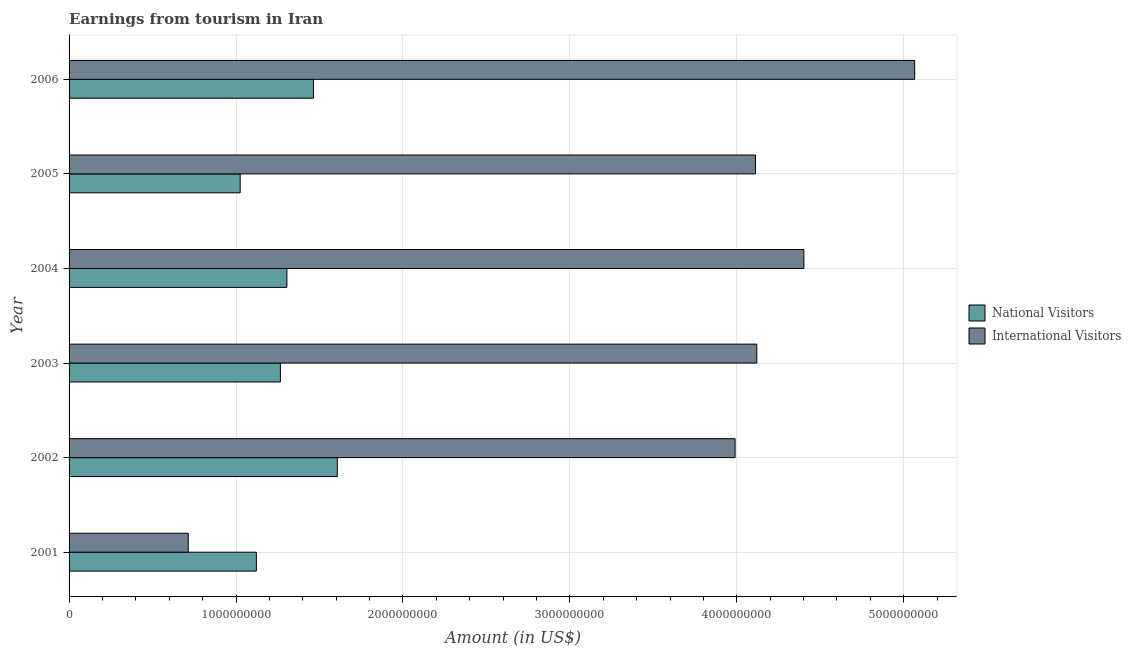How many different coloured bars are there?
Offer a terse response. 2. How many groups of bars are there?
Your response must be concise. 6. Are the number of bars per tick equal to the number of legend labels?
Offer a terse response. Yes. Are the number of bars on each tick of the Y-axis equal?
Offer a terse response. Yes. How many bars are there on the 4th tick from the bottom?
Provide a succinct answer. 2. What is the amount earned from national visitors in 2001?
Your response must be concise. 1.12e+09. Across all years, what is the maximum amount earned from national visitors?
Ensure brevity in your answer.  1.61e+09. Across all years, what is the minimum amount earned from international visitors?
Provide a succinct answer. 7.14e+08. In which year was the amount earned from international visitors maximum?
Provide a succinct answer. 2006. In which year was the amount earned from national visitors minimum?
Your response must be concise. 2005. What is the total amount earned from national visitors in the graph?
Offer a terse response. 7.79e+09. What is the difference between the amount earned from international visitors in 2003 and that in 2004?
Your answer should be compact. -2.82e+08. What is the difference between the amount earned from international visitors in 2001 and the amount earned from national visitors in 2005?
Offer a terse response. -3.11e+08. What is the average amount earned from international visitors per year?
Your response must be concise. 3.73e+09. In the year 2002, what is the difference between the amount earned from national visitors and amount earned from international visitors?
Provide a short and direct response. -2.38e+09. In how many years, is the amount earned from international visitors greater than 4000000000 US$?
Ensure brevity in your answer.  4. What is the ratio of the amount earned from national visitors in 2001 to that in 2002?
Make the answer very short. 0.7. Is the amount earned from national visitors in 2001 less than that in 2004?
Ensure brevity in your answer.  Yes. Is the difference between the amount earned from international visitors in 2001 and 2006 greater than the difference between the amount earned from national visitors in 2001 and 2006?
Your response must be concise. No. What is the difference between the highest and the second highest amount earned from international visitors?
Offer a very short reply. 6.64e+08. What is the difference between the highest and the lowest amount earned from international visitors?
Ensure brevity in your answer.  4.35e+09. What does the 2nd bar from the top in 2006 represents?
Provide a succinct answer. National Visitors. What does the 2nd bar from the bottom in 2002 represents?
Provide a succinct answer. International Visitors. How many years are there in the graph?
Offer a very short reply. 6. Are the values on the major ticks of X-axis written in scientific E-notation?
Make the answer very short. No. Where does the legend appear in the graph?
Your response must be concise. Center right. How many legend labels are there?
Keep it short and to the point. 2. How are the legend labels stacked?
Offer a terse response. Vertical. What is the title of the graph?
Provide a short and direct response. Earnings from tourism in Iran. What is the label or title of the X-axis?
Your answer should be very brief. Amount (in US$). What is the Amount (in US$) of National Visitors in 2001?
Give a very brief answer. 1.12e+09. What is the Amount (in US$) of International Visitors in 2001?
Offer a very short reply. 7.14e+08. What is the Amount (in US$) in National Visitors in 2002?
Your answer should be very brief. 1.61e+09. What is the Amount (in US$) of International Visitors in 2002?
Your answer should be compact. 3.99e+09. What is the Amount (in US$) of National Visitors in 2003?
Make the answer very short. 1.27e+09. What is the Amount (in US$) of International Visitors in 2003?
Your answer should be very brief. 4.12e+09. What is the Amount (in US$) of National Visitors in 2004?
Your answer should be compact. 1.30e+09. What is the Amount (in US$) of International Visitors in 2004?
Offer a very short reply. 4.40e+09. What is the Amount (in US$) of National Visitors in 2005?
Your answer should be compact. 1.02e+09. What is the Amount (in US$) of International Visitors in 2005?
Make the answer very short. 4.11e+09. What is the Amount (in US$) of National Visitors in 2006?
Your answer should be compact. 1.46e+09. What is the Amount (in US$) of International Visitors in 2006?
Ensure brevity in your answer.  5.07e+09. Across all years, what is the maximum Amount (in US$) in National Visitors?
Your response must be concise. 1.61e+09. Across all years, what is the maximum Amount (in US$) in International Visitors?
Offer a very short reply. 5.07e+09. Across all years, what is the minimum Amount (in US$) of National Visitors?
Your response must be concise. 1.02e+09. Across all years, what is the minimum Amount (in US$) in International Visitors?
Provide a short and direct response. 7.14e+08. What is the total Amount (in US$) of National Visitors in the graph?
Offer a terse response. 7.79e+09. What is the total Amount (in US$) in International Visitors in the graph?
Offer a terse response. 2.24e+1. What is the difference between the Amount (in US$) of National Visitors in 2001 and that in 2002?
Offer a very short reply. -4.85e+08. What is the difference between the Amount (in US$) in International Visitors in 2001 and that in 2002?
Make the answer very short. -3.28e+09. What is the difference between the Amount (in US$) of National Visitors in 2001 and that in 2003?
Keep it short and to the point. -1.44e+08. What is the difference between the Amount (in US$) of International Visitors in 2001 and that in 2003?
Offer a very short reply. -3.41e+09. What is the difference between the Amount (in US$) of National Visitors in 2001 and that in 2004?
Offer a very short reply. -1.83e+08. What is the difference between the Amount (in US$) of International Visitors in 2001 and that in 2004?
Offer a very short reply. -3.69e+09. What is the difference between the Amount (in US$) of National Visitors in 2001 and that in 2005?
Keep it short and to the point. 9.70e+07. What is the difference between the Amount (in US$) in International Visitors in 2001 and that in 2005?
Provide a short and direct response. -3.40e+09. What is the difference between the Amount (in US$) of National Visitors in 2001 and that in 2006?
Offer a very short reply. -3.42e+08. What is the difference between the Amount (in US$) of International Visitors in 2001 and that in 2006?
Make the answer very short. -4.35e+09. What is the difference between the Amount (in US$) in National Visitors in 2002 and that in 2003?
Offer a very short reply. 3.41e+08. What is the difference between the Amount (in US$) in International Visitors in 2002 and that in 2003?
Offer a very short reply. -1.30e+08. What is the difference between the Amount (in US$) of National Visitors in 2002 and that in 2004?
Your answer should be very brief. 3.02e+08. What is the difference between the Amount (in US$) in International Visitors in 2002 and that in 2004?
Give a very brief answer. -4.12e+08. What is the difference between the Amount (in US$) of National Visitors in 2002 and that in 2005?
Offer a very short reply. 5.82e+08. What is the difference between the Amount (in US$) of International Visitors in 2002 and that in 2005?
Offer a very short reply. -1.22e+08. What is the difference between the Amount (in US$) of National Visitors in 2002 and that in 2006?
Your answer should be compact. 1.43e+08. What is the difference between the Amount (in US$) in International Visitors in 2002 and that in 2006?
Your answer should be compact. -1.08e+09. What is the difference between the Amount (in US$) in National Visitors in 2003 and that in 2004?
Offer a very short reply. -3.90e+07. What is the difference between the Amount (in US$) in International Visitors in 2003 and that in 2004?
Offer a very short reply. -2.82e+08. What is the difference between the Amount (in US$) of National Visitors in 2003 and that in 2005?
Your answer should be compact. 2.41e+08. What is the difference between the Amount (in US$) in International Visitors in 2003 and that in 2005?
Give a very brief answer. 8.00e+06. What is the difference between the Amount (in US$) of National Visitors in 2003 and that in 2006?
Keep it short and to the point. -1.98e+08. What is the difference between the Amount (in US$) in International Visitors in 2003 and that in 2006?
Give a very brief answer. -9.46e+08. What is the difference between the Amount (in US$) of National Visitors in 2004 and that in 2005?
Offer a very short reply. 2.80e+08. What is the difference between the Amount (in US$) of International Visitors in 2004 and that in 2005?
Offer a terse response. 2.90e+08. What is the difference between the Amount (in US$) in National Visitors in 2004 and that in 2006?
Your answer should be very brief. -1.59e+08. What is the difference between the Amount (in US$) of International Visitors in 2004 and that in 2006?
Give a very brief answer. -6.64e+08. What is the difference between the Amount (in US$) of National Visitors in 2005 and that in 2006?
Make the answer very short. -4.39e+08. What is the difference between the Amount (in US$) of International Visitors in 2005 and that in 2006?
Your answer should be compact. -9.54e+08. What is the difference between the Amount (in US$) in National Visitors in 2001 and the Amount (in US$) in International Visitors in 2002?
Your response must be concise. -2.87e+09. What is the difference between the Amount (in US$) in National Visitors in 2001 and the Amount (in US$) in International Visitors in 2003?
Offer a terse response. -3.00e+09. What is the difference between the Amount (in US$) in National Visitors in 2001 and the Amount (in US$) in International Visitors in 2004?
Your answer should be compact. -3.28e+09. What is the difference between the Amount (in US$) of National Visitors in 2001 and the Amount (in US$) of International Visitors in 2005?
Your answer should be compact. -2.99e+09. What is the difference between the Amount (in US$) of National Visitors in 2001 and the Amount (in US$) of International Visitors in 2006?
Provide a short and direct response. -3.94e+09. What is the difference between the Amount (in US$) in National Visitors in 2002 and the Amount (in US$) in International Visitors in 2003?
Your answer should be very brief. -2.51e+09. What is the difference between the Amount (in US$) in National Visitors in 2002 and the Amount (in US$) in International Visitors in 2004?
Provide a succinct answer. -2.80e+09. What is the difference between the Amount (in US$) in National Visitors in 2002 and the Amount (in US$) in International Visitors in 2005?
Provide a succinct answer. -2.50e+09. What is the difference between the Amount (in US$) in National Visitors in 2002 and the Amount (in US$) in International Visitors in 2006?
Ensure brevity in your answer.  -3.46e+09. What is the difference between the Amount (in US$) in National Visitors in 2003 and the Amount (in US$) in International Visitors in 2004?
Your answer should be compact. -3.14e+09. What is the difference between the Amount (in US$) in National Visitors in 2003 and the Amount (in US$) in International Visitors in 2005?
Provide a short and direct response. -2.85e+09. What is the difference between the Amount (in US$) of National Visitors in 2003 and the Amount (in US$) of International Visitors in 2006?
Your answer should be compact. -3.80e+09. What is the difference between the Amount (in US$) of National Visitors in 2004 and the Amount (in US$) of International Visitors in 2005?
Make the answer very short. -2.81e+09. What is the difference between the Amount (in US$) of National Visitors in 2004 and the Amount (in US$) of International Visitors in 2006?
Your answer should be very brief. -3.76e+09. What is the difference between the Amount (in US$) in National Visitors in 2005 and the Amount (in US$) in International Visitors in 2006?
Give a very brief answer. -4.04e+09. What is the average Amount (in US$) of National Visitors per year?
Offer a terse response. 1.30e+09. What is the average Amount (in US$) of International Visitors per year?
Provide a short and direct response. 3.73e+09. In the year 2001, what is the difference between the Amount (in US$) in National Visitors and Amount (in US$) in International Visitors?
Your answer should be compact. 4.08e+08. In the year 2002, what is the difference between the Amount (in US$) of National Visitors and Amount (in US$) of International Visitors?
Your answer should be compact. -2.38e+09. In the year 2003, what is the difference between the Amount (in US$) of National Visitors and Amount (in US$) of International Visitors?
Keep it short and to the point. -2.85e+09. In the year 2004, what is the difference between the Amount (in US$) in National Visitors and Amount (in US$) in International Visitors?
Offer a very short reply. -3.10e+09. In the year 2005, what is the difference between the Amount (in US$) of National Visitors and Amount (in US$) of International Visitors?
Ensure brevity in your answer.  -3.09e+09. In the year 2006, what is the difference between the Amount (in US$) of National Visitors and Amount (in US$) of International Visitors?
Give a very brief answer. -3.60e+09. What is the ratio of the Amount (in US$) of National Visitors in 2001 to that in 2002?
Ensure brevity in your answer.  0.7. What is the ratio of the Amount (in US$) in International Visitors in 2001 to that in 2002?
Keep it short and to the point. 0.18. What is the ratio of the Amount (in US$) in National Visitors in 2001 to that in 2003?
Keep it short and to the point. 0.89. What is the ratio of the Amount (in US$) in International Visitors in 2001 to that in 2003?
Offer a terse response. 0.17. What is the ratio of the Amount (in US$) in National Visitors in 2001 to that in 2004?
Ensure brevity in your answer.  0.86. What is the ratio of the Amount (in US$) of International Visitors in 2001 to that in 2004?
Provide a short and direct response. 0.16. What is the ratio of the Amount (in US$) of National Visitors in 2001 to that in 2005?
Keep it short and to the point. 1.09. What is the ratio of the Amount (in US$) in International Visitors in 2001 to that in 2005?
Make the answer very short. 0.17. What is the ratio of the Amount (in US$) in National Visitors in 2001 to that in 2006?
Keep it short and to the point. 0.77. What is the ratio of the Amount (in US$) of International Visitors in 2001 to that in 2006?
Offer a terse response. 0.14. What is the ratio of the Amount (in US$) of National Visitors in 2002 to that in 2003?
Provide a succinct answer. 1.27. What is the ratio of the Amount (in US$) in International Visitors in 2002 to that in 2003?
Your response must be concise. 0.97. What is the ratio of the Amount (in US$) in National Visitors in 2002 to that in 2004?
Provide a short and direct response. 1.23. What is the ratio of the Amount (in US$) of International Visitors in 2002 to that in 2004?
Keep it short and to the point. 0.91. What is the ratio of the Amount (in US$) of National Visitors in 2002 to that in 2005?
Your answer should be compact. 1.57. What is the ratio of the Amount (in US$) in International Visitors in 2002 to that in 2005?
Ensure brevity in your answer.  0.97. What is the ratio of the Amount (in US$) in National Visitors in 2002 to that in 2006?
Your answer should be very brief. 1.1. What is the ratio of the Amount (in US$) in International Visitors in 2002 to that in 2006?
Your answer should be compact. 0.79. What is the ratio of the Amount (in US$) of National Visitors in 2003 to that in 2004?
Your response must be concise. 0.97. What is the ratio of the Amount (in US$) of International Visitors in 2003 to that in 2004?
Offer a terse response. 0.94. What is the ratio of the Amount (in US$) of National Visitors in 2003 to that in 2005?
Your response must be concise. 1.24. What is the ratio of the Amount (in US$) in International Visitors in 2003 to that in 2005?
Give a very brief answer. 1. What is the ratio of the Amount (in US$) in National Visitors in 2003 to that in 2006?
Provide a succinct answer. 0.86. What is the ratio of the Amount (in US$) in International Visitors in 2003 to that in 2006?
Ensure brevity in your answer.  0.81. What is the ratio of the Amount (in US$) of National Visitors in 2004 to that in 2005?
Offer a terse response. 1.27. What is the ratio of the Amount (in US$) of International Visitors in 2004 to that in 2005?
Your answer should be compact. 1.07. What is the ratio of the Amount (in US$) of National Visitors in 2004 to that in 2006?
Make the answer very short. 0.89. What is the ratio of the Amount (in US$) in International Visitors in 2004 to that in 2006?
Give a very brief answer. 0.87. What is the ratio of the Amount (in US$) of National Visitors in 2005 to that in 2006?
Offer a very short reply. 0.7. What is the ratio of the Amount (in US$) of International Visitors in 2005 to that in 2006?
Provide a short and direct response. 0.81. What is the difference between the highest and the second highest Amount (in US$) in National Visitors?
Your response must be concise. 1.43e+08. What is the difference between the highest and the second highest Amount (in US$) of International Visitors?
Your answer should be compact. 6.64e+08. What is the difference between the highest and the lowest Amount (in US$) in National Visitors?
Provide a short and direct response. 5.82e+08. What is the difference between the highest and the lowest Amount (in US$) in International Visitors?
Your answer should be compact. 4.35e+09. 